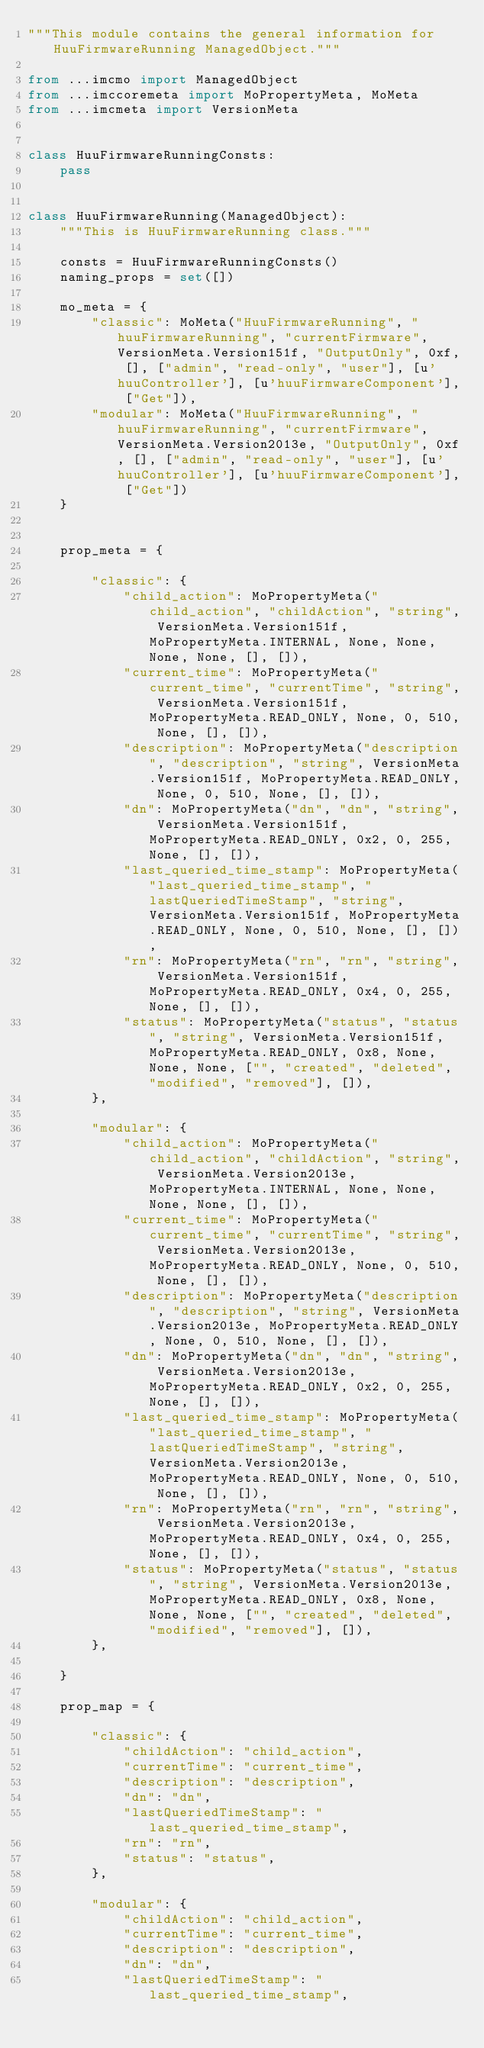<code> <loc_0><loc_0><loc_500><loc_500><_Python_>"""This module contains the general information for HuuFirmwareRunning ManagedObject."""

from ...imcmo import ManagedObject
from ...imccoremeta import MoPropertyMeta, MoMeta
from ...imcmeta import VersionMeta


class HuuFirmwareRunningConsts:
    pass


class HuuFirmwareRunning(ManagedObject):
    """This is HuuFirmwareRunning class."""

    consts = HuuFirmwareRunningConsts()
    naming_props = set([])

    mo_meta = {
        "classic": MoMeta("HuuFirmwareRunning", "huuFirmwareRunning", "currentFirmware", VersionMeta.Version151f, "OutputOnly", 0xf, [], ["admin", "read-only", "user"], [u'huuController'], [u'huuFirmwareComponent'], ["Get"]),
        "modular": MoMeta("HuuFirmwareRunning", "huuFirmwareRunning", "currentFirmware", VersionMeta.Version2013e, "OutputOnly", 0xf, [], ["admin", "read-only", "user"], [u'huuController'], [u'huuFirmwareComponent'], ["Get"])
    }


    prop_meta = {

        "classic": {
            "child_action": MoPropertyMeta("child_action", "childAction", "string", VersionMeta.Version151f, MoPropertyMeta.INTERNAL, None, None, None, None, [], []), 
            "current_time": MoPropertyMeta("current_time", "currentTime", "string", VersionMeta.Version151f, MoPropertyMeta.READ_ONLY, None, 0, 510, None, [], []), 
            "description": MoPropertyMeta("description", "description", "string", VersionMeta.Version151f, MoPropertyMeta.READ_ONLY, None, 0, 510, None, [], []), 
            "dn": MoPropertyMeta("dn", "dn", "string", VersionMeta.Version151f, MoPropertyMeta.READ_ONLY, 0x2, 0, 255, None, [], []), 
            "last_queried_time_stamp": MoPropertyMeta("last_queried_time_stamp", "lastQueriedTimeStamp", "string", VersionMeta.Version151f, MoPropertyMeta.READ_ONLY, None, 0, 510, None, [], []), 
            "rn": MoPropertyMeta("rn", "rn", "string", VersionMeta.Version151f, MoPropertyMeta.READ_ONLY, 0x4, 0, 255, None, [], []), 
            "status": MoPropertyMeta("status", "status", "string", VersionMeta.Version151f, MoPropertyMeta.READ_ONLY, 0x8, None, None, None, ["", "created", "deleted", "modified", "removed"], []), 
        },

        "modular": {
            "child_action": MoPropertyMeta("child_action", "childAction", "string", VersionMeta.Version2013e, MoPropertyMeta.INTERNAL, None, None, None, None, [], []), 
            "current_time": MoPropertyMeta("current_time", "currentTime", "string", VersionMeta.Version2013e, MoPropertyMeta.READ_ONLY, None, 0, 510, None, [], []), 
            "description": MoPropertyMeta("description", "description", "string", VersionMeta.Version2013e, MoPropertyMeta.READ_ONLY, None, 0, 510, None, [], []), 
            "dn": MoPropertyMeta("dn", "dn", "string", VersionMeta.Version2013e, MoPropertyMeta.READ_ONLY, 0x2, 0, 255, None, [], []), 
            "last_queried_time_stamp": MoPropertyMeta("last_queried_time_stamp", "lastQueriedTimeStamp", "string", VersionMeta.Version2013e, MoPropertyMeta.READ_ONLY, None, 0, 510, None, [], []), 
            "rn": MoPropertyMeta("rn", "rn", "string", VersionMeta.Version2013e, MoPropertyMeta.READ_ONLY, 0x4, 0, 255, None, [], []), 
            "status": MoPropertyMeta("status", "status", "string", VersionMeta.Version2013e, MoPropertyMeta.READ_ONLY, 0x8, None, None, None, ["", "created", "deleted", "modified", "removed"], []), 
        },

    }

    prop_map = {

        "classic": {
            "childAction": "child_action", 
            "currentTime": "current_time", 
            "description": "description", 
            "dn": "dn", 
            "lastQueriedTimeStamp": "last_queried_time_stamp", 
            "rn": "rn", 
            "status": "status", 
        },

        "modular": {
            "childAction": "child_action", 
            "currentTime": "current_time", 
            "description": "description", 
            "dn": "dn", 
            "lastQueriedTimeStamp": "last_queried_time_stamp", </code> 